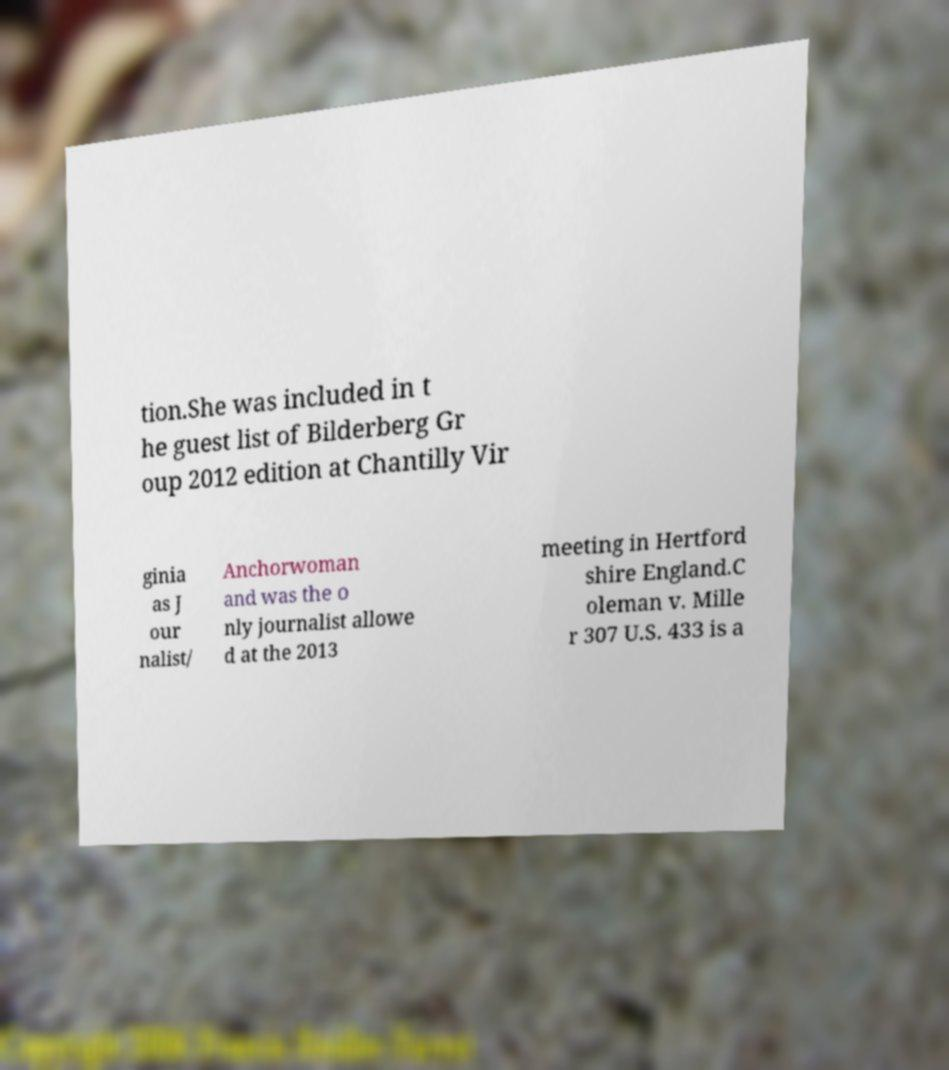Can you accurately transcribe the text from the provided image for me? tion.She was included in t he guest list of Bilderberg Gr oup 2012 edition at Chantilly Vir ginia as J our nalist/ Anchorwoman and was the o nly journalist allowe d at the 2013 meeting in Hertford shire England.C oleman v. Mille r 307 U.S. 433 is a 